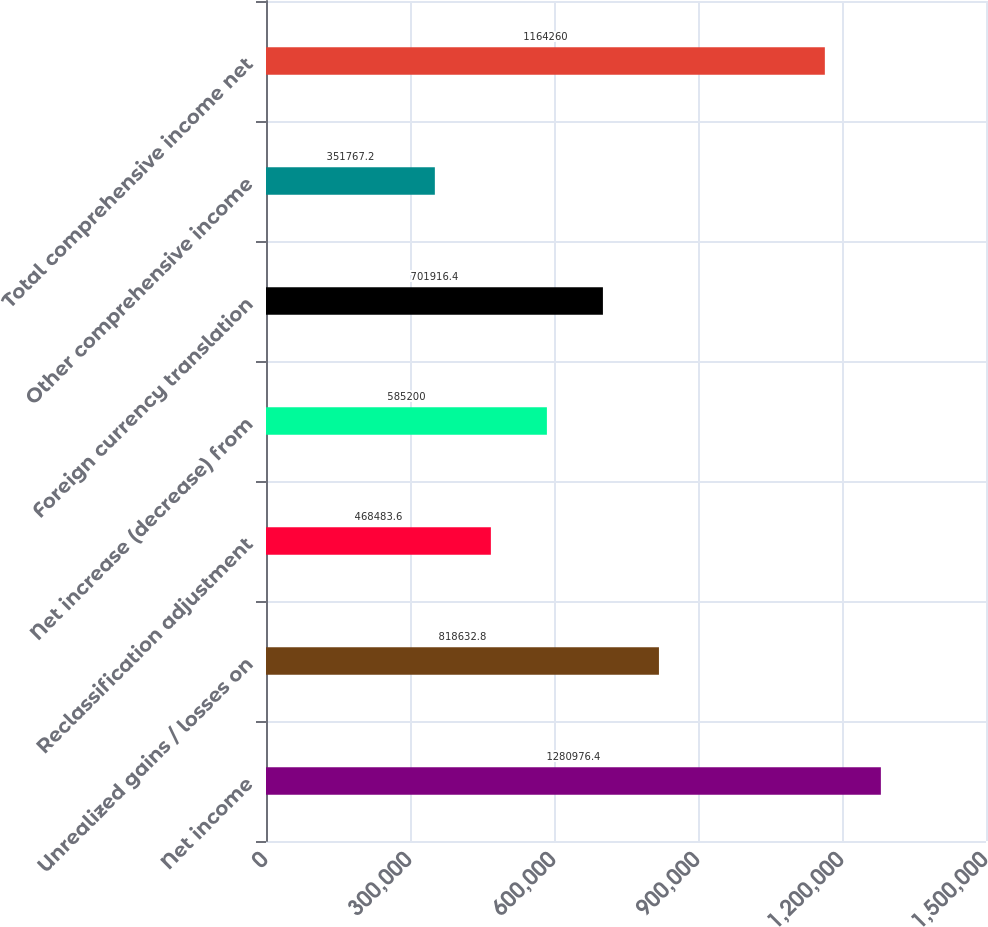Convert chart. <chart><loc_0><loc_0><loc_500><loc_500><bar_chart><fcel>Net income<fcel>Unrealized gains / losses on<fcel>Reclassification adjustment<fcel>Net increase (decrease) from<fcel>Foreign currency translation<fcel>Other comprehensive income<fcel>Total comprehensive income net<nl><fcel>1.28098e+06<fcel>818633<fcel>468484<fcel>585200<fcel>701916<fcel>351767<fcel>1.16426e+06<nl></chart> 